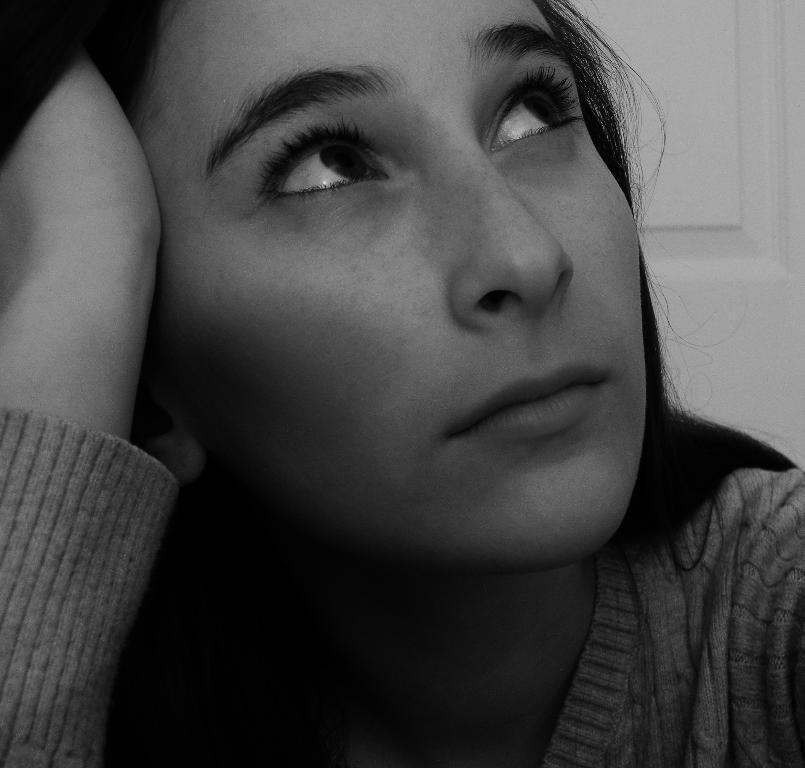Please provide a concise description of this image. In this image we can see a lady. In the background there is a door. 